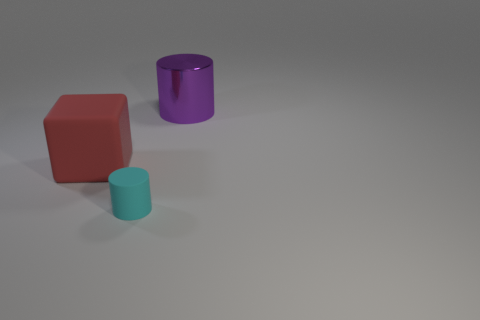Add 3 tiny purple balls. How many objects exist? 6 Subtract all cylinders. How many objects are left? 1 Add 2 big red cylinders. How many big red cylinders exist? 2 Subtract 0 green cubes. How many objects are left? 3 Subtract all small cylinders. Subtract all tiny cyan cylinders. How many objects are left? 1 Add 2 tiny cyan rubber cylinders. How many tiny cyan rubber cylinders are left? 3 